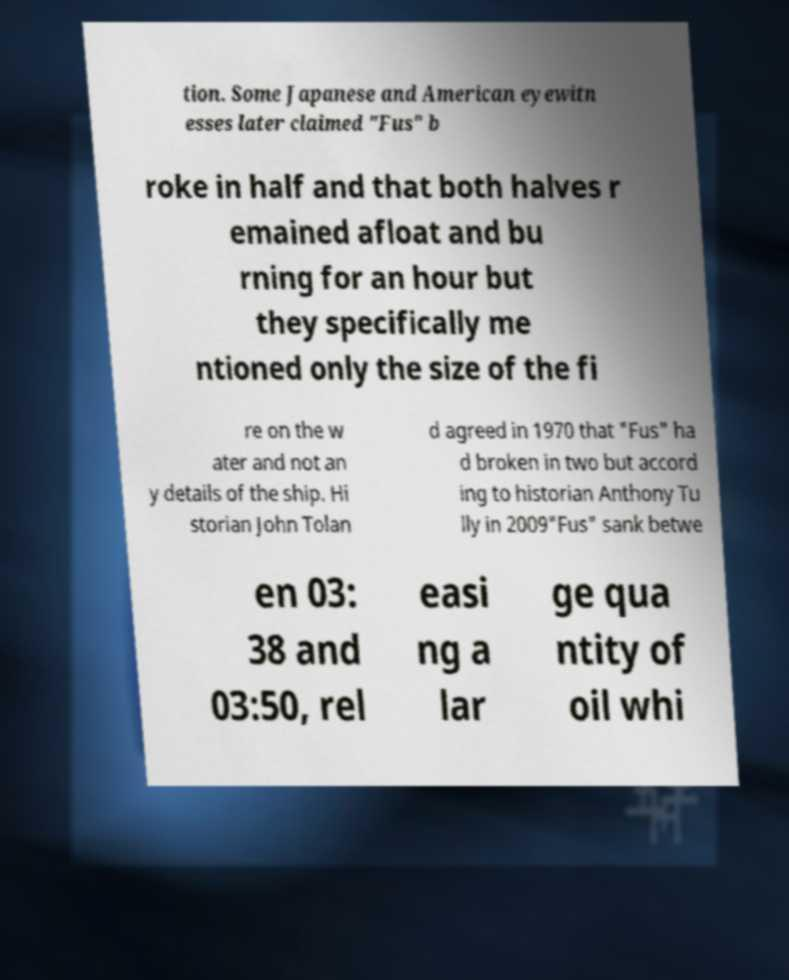Please identify and transcribe the text found in this image. tion. Some Japanese and American eyewitn esses later claimed "Fus" b roke in half and that both halves r emained afloat and bu rning for an hour but they specifically me ntioned only the size of the fi re on the w ater and not an y details of the ship. Hi storian John Tolan d agreed in 1970 that "Fus" ha d broken in two but accord ing to historian Anthony Tu lly in 2009"Fus" sank betwe en 03: 38 and 03:50, rel easi ng a lar ge qua ntity of oil whi 